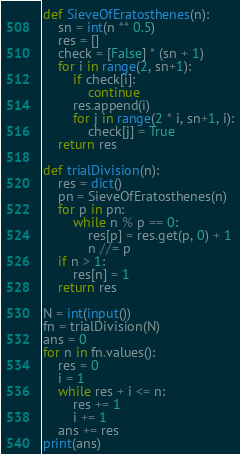Convert code to text. <code><loc_0><loc_0><loc_500><loc_500><_Python_>def SieveOfEratosthenes(n):
    sn = int(n ** 0.5)
    res = []
    check = [False] * (sn + 1)
    for i in range(2, sn+1):
        if check[i]:
            continue
        res.append(i)
        for j in range(2 * i, sn+1, i):
            check[j] = True
    return res

def trialDivision(n):
    res = dict()
    pn = SieveOfEratosthenes(n)
    for p in pn:
        while n % p == 0:
            res[p] = res.get(p, 0) + 1
            n //= p
    if n > 1:
        res[n] = 1
    return res

N = int(input())
fn = trialDivision(N)
ans = 0
for n in fn.values():
    res = 0
    i = 1
    while res + i <= n:
        res += 1
        i += 1
    ans += res
print(ans)</code> 